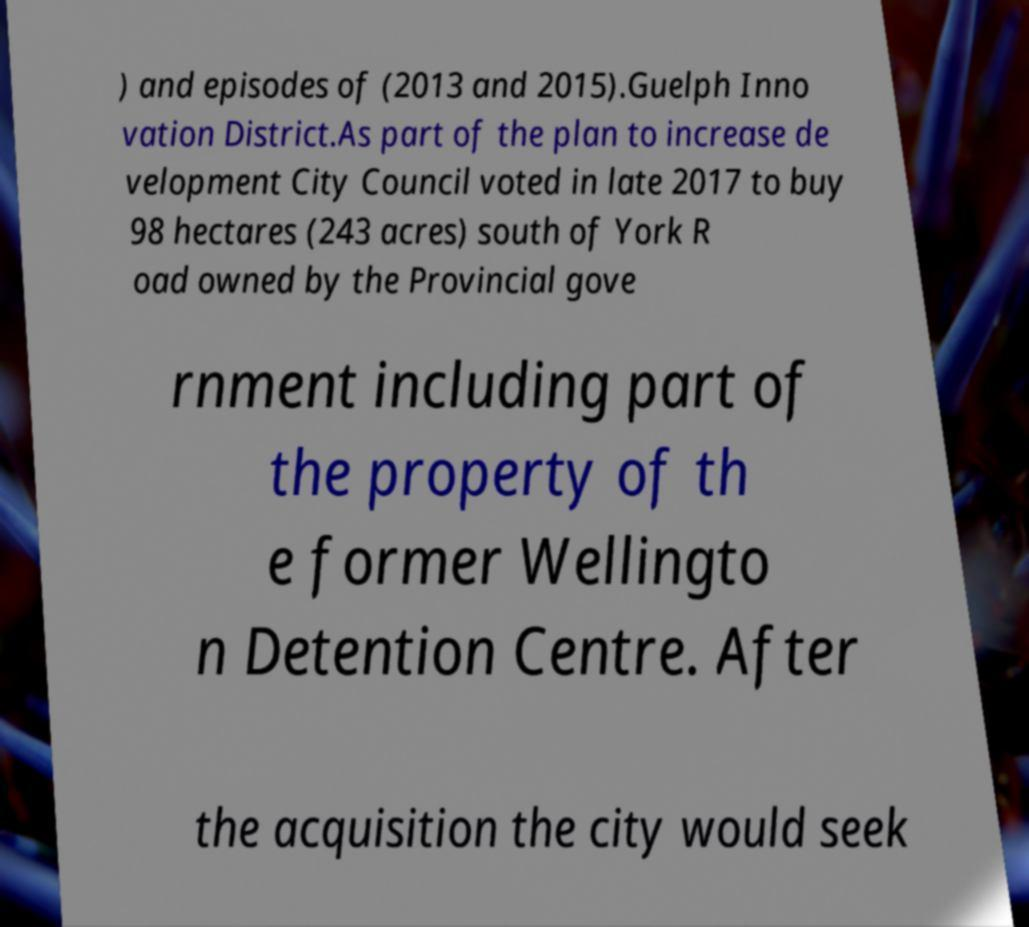What messages or text are displayed in this image? I need them in a readable, typed format. ) and episodes of (2013 and 2015).Guelph Inno vation District.As part of the plan to increase de velopment City Council voted in late 2017 to buy 98 hectares (243 acres) south of York R oad owned by the Provincial gove rnment including part of the property of th e former Wellingto n Detention Centre. After the acquisition the city would seek 